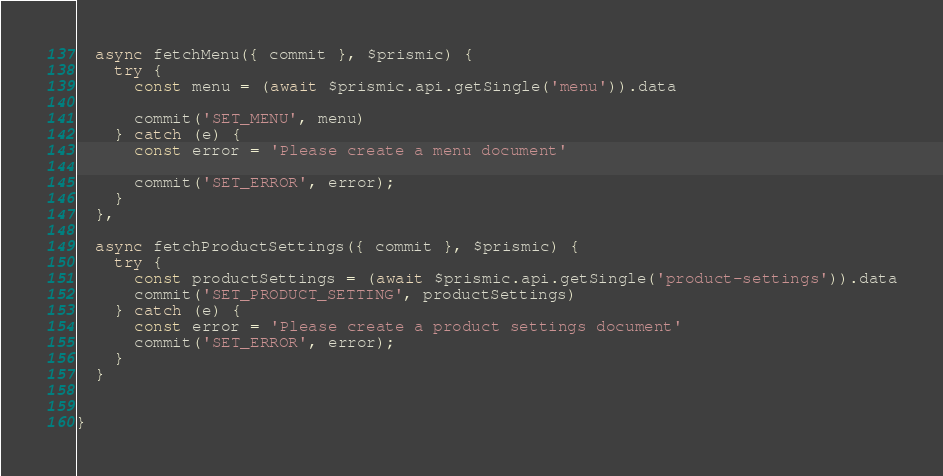<code> <loc_0><loc_0><loc_500><loc_500><_JavaScript_>
  async fetchMenu({ commit }, $prismic) {
    try {
      const menu = (await $prismic.api.getSingle('menu')).data

      commit('SET_MENU', menu)
    } catch (e) {
      const error = 'Please create a menu document'

      commit('SET_ERROR', error);
    }
  },

  async fetchProductSettings({ commit }, $prismic) {
    try {
      const productSettings = (await $prismic.api.getSingle('product-settings')).data
      commit('SET_PRODUCT_SETTING', productSettings)
    } catch (e) {
      const error = 'Please create a product settings document'
      commit('SET_ERROR', error);
    }
  }


}
</code> 